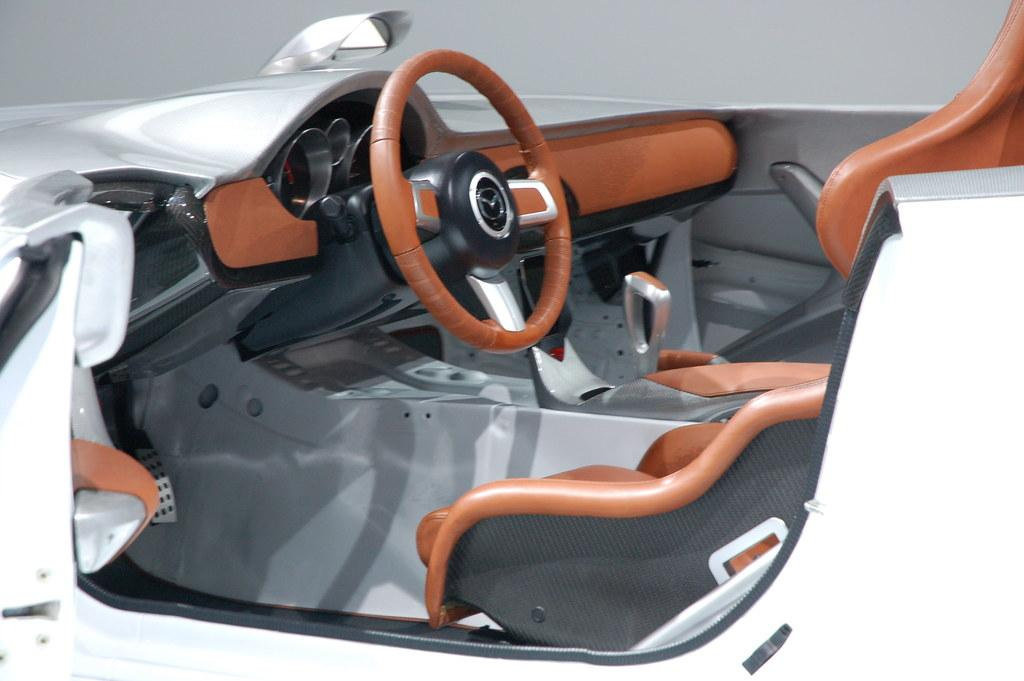What is the main subject of the image? There is a vehicle in the image. Can you describe the color of the vehicle? The vehicle is white in color. What can be seen in the background of the image? There is a cream-colored background at the back of the image. How much oil is required to maintain the vehicle in the image? There is no information about the vehicle's maintenance or oil requirements in the image. 